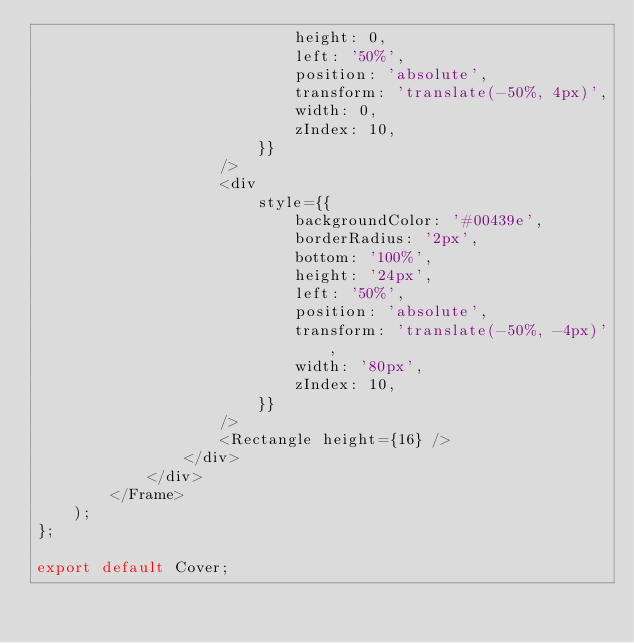Convert code to text. <code><loc_0><loc_0><loc_500><loc_500><_TypeScript_>                            height: 0,
                            left: '50%',
                            position: 'absolute',
                            transform: 'translate(-50%, 4px)',
                            width: 0,
                            zIndex: 10,
                        }}
                    />
                    <div
                        style={{
                            backgroundColor: '#00439e',
                            borderRadius: '2px',
                            bottom: '100%',
                            height: '24px',
                            left: '50%',
                            position: 'absolute',
                            transform: 'translate(-50%, -4px)',
                            width: '80px',
                            zIndex: 10,
                        }}
                    />
                    <Rectangle height={16} />
                </div>
            </div>
        </Frame>
    );
};

export default Cover;
</code> 